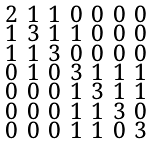Convert formula to latex. <formula><loc_0><loc_0><loc_500><loc_500>\begin{smallmatrix} 2 & 1 & 1 & 0 & 0 & 0 & 0 \\ 1 & 3 & 1 & 1 & 0 & 0 & 0 \\ 1 & 1 & 3 & 0 & 0 & 0 & 0 \\ 0 & 1 & 0 & 3 & 1 & 1 & 1 \\ 0 & 0 & 0 & 1 & 3 & 1 & 1 \\ 0 & 0 & 0 & 1 & 1 & 3 & 0 \\ 0 & 0 & 0 & 1 & 1 & 0 & 3 \end{smallmatrix}</formula> 